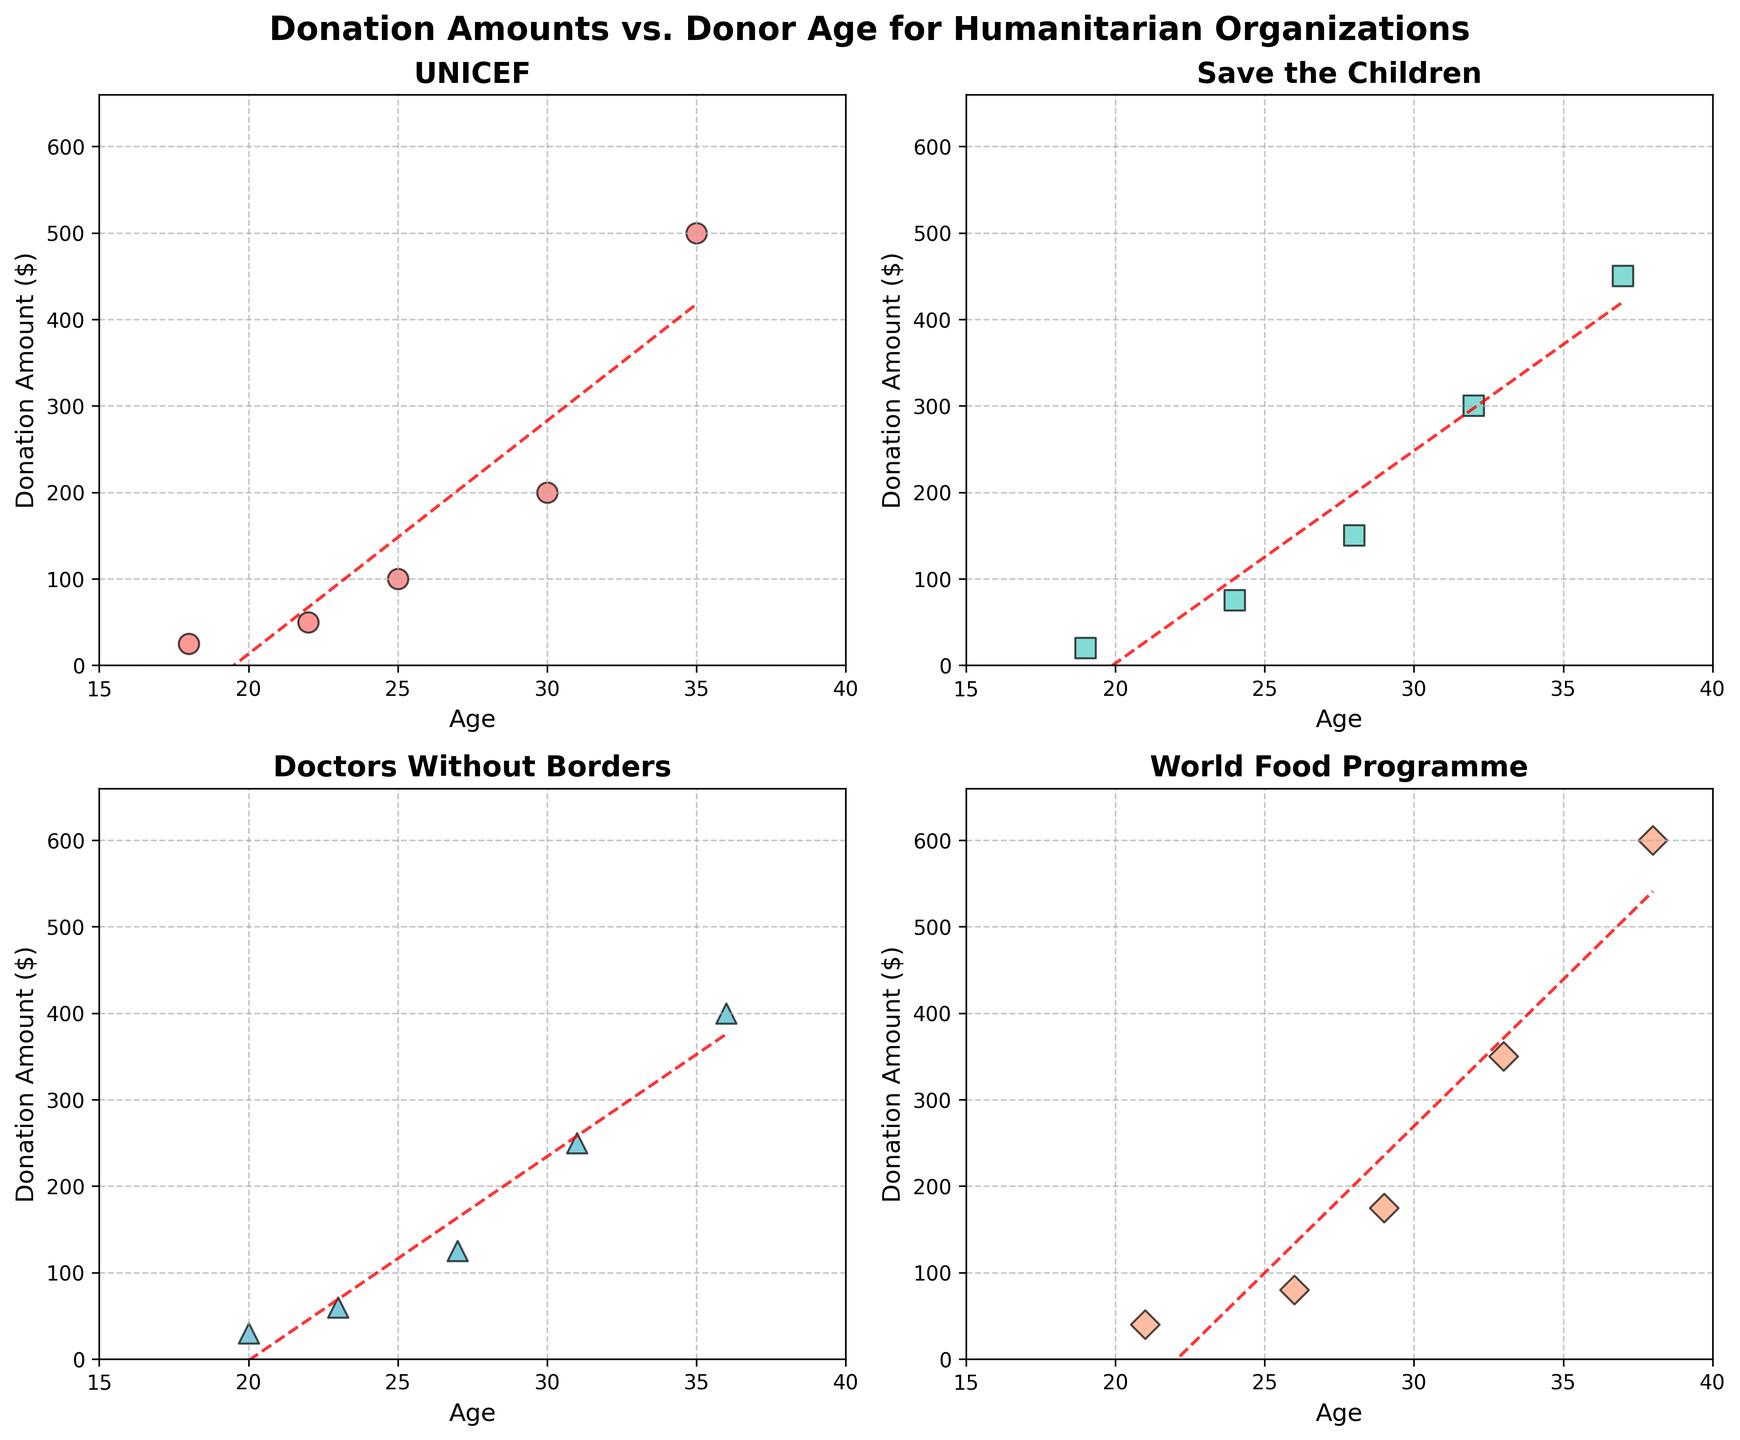What's the title of the figure? The title is found at the top of the figure and usually in a larger font size. Here, the title is "Donation Amounts vs. Donor Age for Humanitarian Organizations".
Answer: Donation Amounts vs. Donor Age for Humanitarian Organizations What is the x-axis label for each subplot? Each subplot has labels on the x-axis that indicate the measurement being plotted. All subplots have 'Age' as the x-axis label.
Answer: Age How many different organizations are represented in the figure? By visually counting the number of subplots present, we see there are four subplots, each representing a different organization.
Answer: 4 Which organization has the highest donation amount plotted, and what is that value? By scanning all subplots, the maximum donation amount can be found in the World Food Programme subplot, which is $600.
Answer: World Food Programme, $600 Is there a trend between age and donation amount for Doctors Without Borders? Observing the scatter plot and the trend line (red dashed line), an upward trend is evident, indicating donation amounts increase with age.
Answer: Increasing trend Which age group has the lowest donation amount for Save the Children? By examining the earliest age data point in the Save the Children subplot, the lowest donation amount is at age 19, with a donation of $20.
Answer: Age 19 What is the average donation amount for individuals aged 25 across all organizations? Locate and sum donations at age 25 for UNICEF ($100) and World Food Programme (no data at age 25). Therefore, the average is $100 / 1 = $100.
Answer: $100 Compare the donations of 30-year-olds across different organizations. Which organization received the highest donation and what was the amount? Look at the 30-year-old donor points in each subplot. UNICEF has a 30-year-old donating $200, which is higher than the others at this age.
Answer: UNICEF, $200 What are the donation amounts for 32-year-olds in the dataset? Refer to subplots for any points at age 32: Save the Children has a donation of $300 at this age. No other organizations have data points for age 32.
Answer: $300 